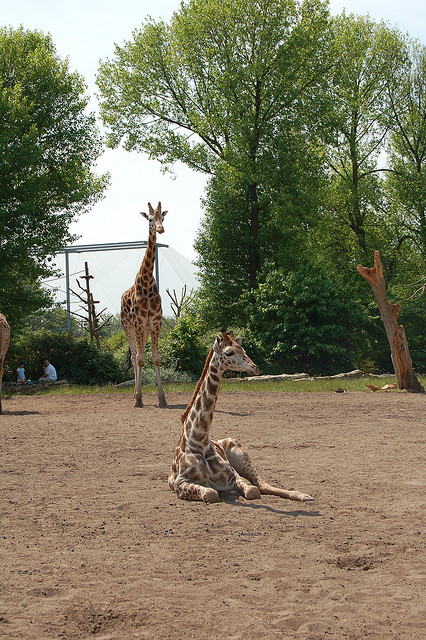<image>Is this a recent photo? I don't know if this is a recent photo. What kind of trees are in the background? I don't know what kind of trees are in the background. They could be aspen, acacia, african, maple, deciduous, or oak trees. Is this a recent photo? I am not sure if this is a recent photo. It can be recent or not. What kind of trees are in the background? I don't know what kind of trees are in the background. It could be aspen, acacia, African, maple, or oak. 